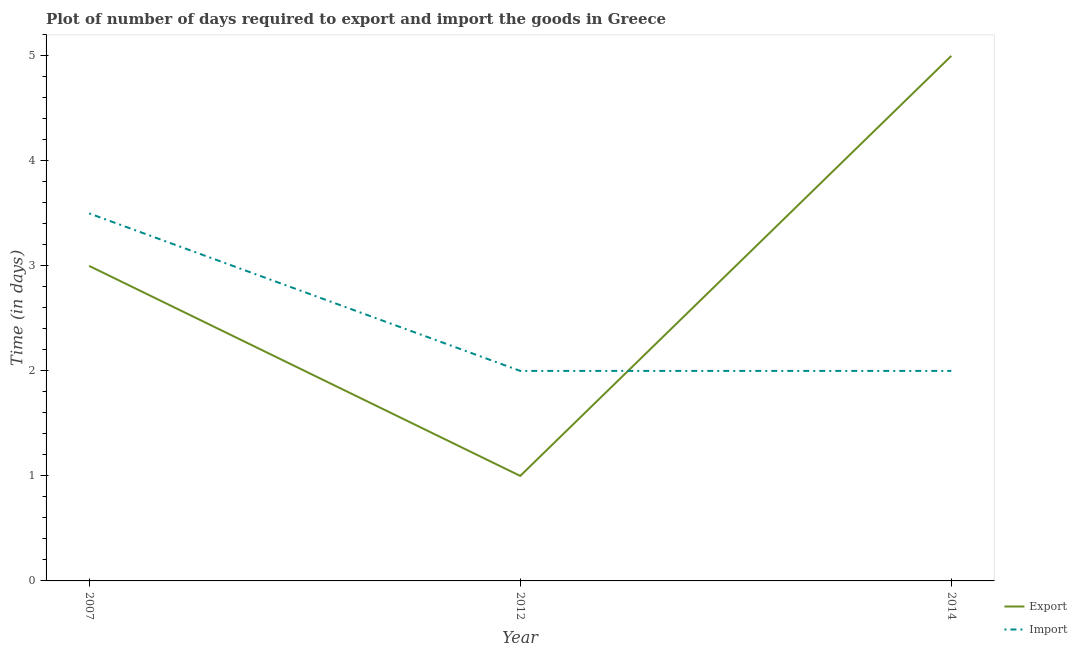How many different coloured lines are there?
Give a very brief answer. 2. What is the time required to export in 2007?
Give a very brief answer. 3. Across all years, what is the maximum time required to export?
Your answer should be very brief. 5. Across all years, what is the minimum time required to import?
Keep it short and to the point. 2. In which year was the time required to import minimum?
Ensure brevity in your answer.  2012. What is the total time required to export in the graph?
Your answer should be compact. 9. What is the difference between the time required to import in 2012 and that in 2014?
Your answer should be compact. 0. What is the difference between the time required to import in 2014 and the time required to export in 2007?
Give a very brief answer. -1. Does the time required to export monotonically increase over the years?
Ensure brevity in your answer.  No. Is the time required to import strictly greater than the time required to export over the years?
Your answer should be compact. No. How are the legend labels stacked?
Give a very brief answer. Vertical. What is the title of the graph?
Your answer should be very brief. Plot of number of days required to export and import the goods in Greece. Does "Female" appear as one of the legend labels in the graph?
Keep it short and to the point. No. What is the label or title of the X-axis?
Offer a very short reply. Year. What is the label or title of the Y-axis?
Your answer should be compact. Time (in days). What is the Time (in days) in Export in 2007?
Give a very brief answer. 3. What is the Time (in days) in Import in 2007?
Provide a short and direct response. 3.5. What is the Time (in days) of Import in 2012?
Provide a succinct answer. 2. Across all years, what is the maximum Time (in days) in Export?
Ensure brevity in your answer.  5. Across all years, what is the minimum Time (in days) of Import?
Ensure brevity in your answer.  2. What is the difference between the Time (in days) in Export in 2007 and that in 2012?
Give a very brief answer. 2. What is the difference between the Time (in days) of Import in 2012 and that in 2014?
Offer a terse response. 0. What is the difference between the Time (in days) of Export in 2007 and the Time (in days) of Import in 2012?
Offer a terse response. 1. In the year 2012, what is the difference between the Time (in days) in Export and Time (in days) in Import?
Provide a succinct answer. -1. What is the ratio of the Time (in days) of Export in 2007 to that in 2014?
Offer a very short reply. 0.6. What is the ratio of the Time (in days) of Import in 2007 to that in 2014?
Your answer should be compact. 1.75. What is the ratio of the Time (in days) of Export in 2012 to that in 2014?
Your response must be concise. 0.2. What is the difference between the highest and the second highest Time (in days) in Import?
Your response must be concise. 1.5. What is the difference between the highest and the lowest Time (in days) of Export?
Offer a terse response. 4. What is the difference between the highest and the lowest Time (in days) of Import?
Give a very brief answer. 1.5. 